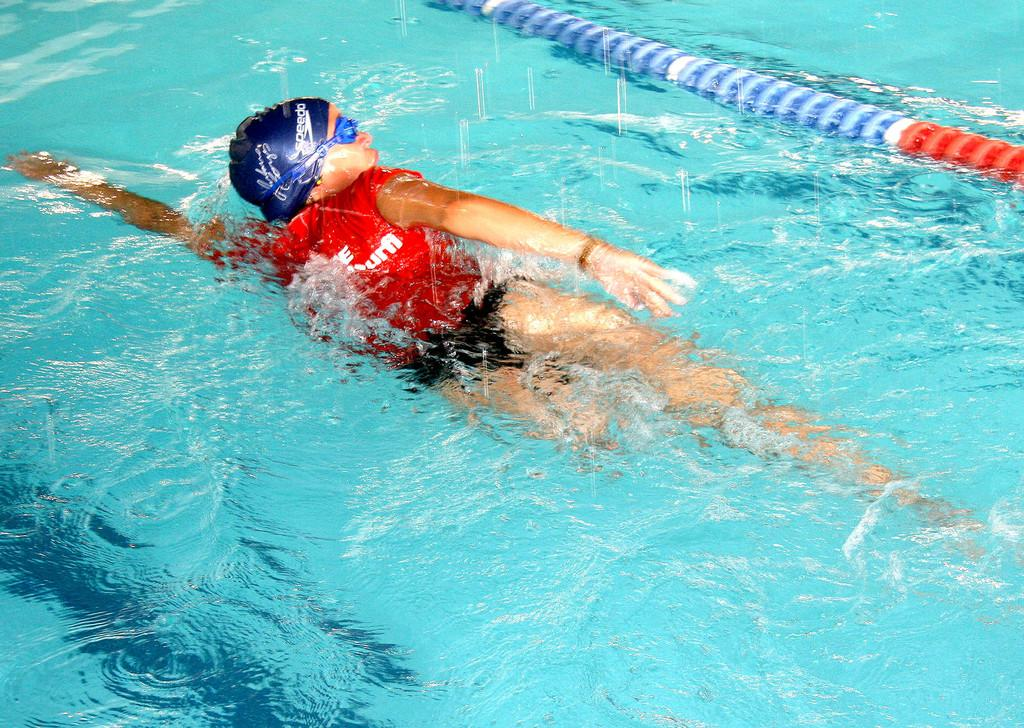What is the main activity of the person in the image? There is a person swimming in the image. What can be seen at the top of the image? There is a pipe at the top of the image. What type of drum can be seen floating in the water next to the person swimming? There is no drum present in the image; it only features a person swimming and a pipe at the top. 